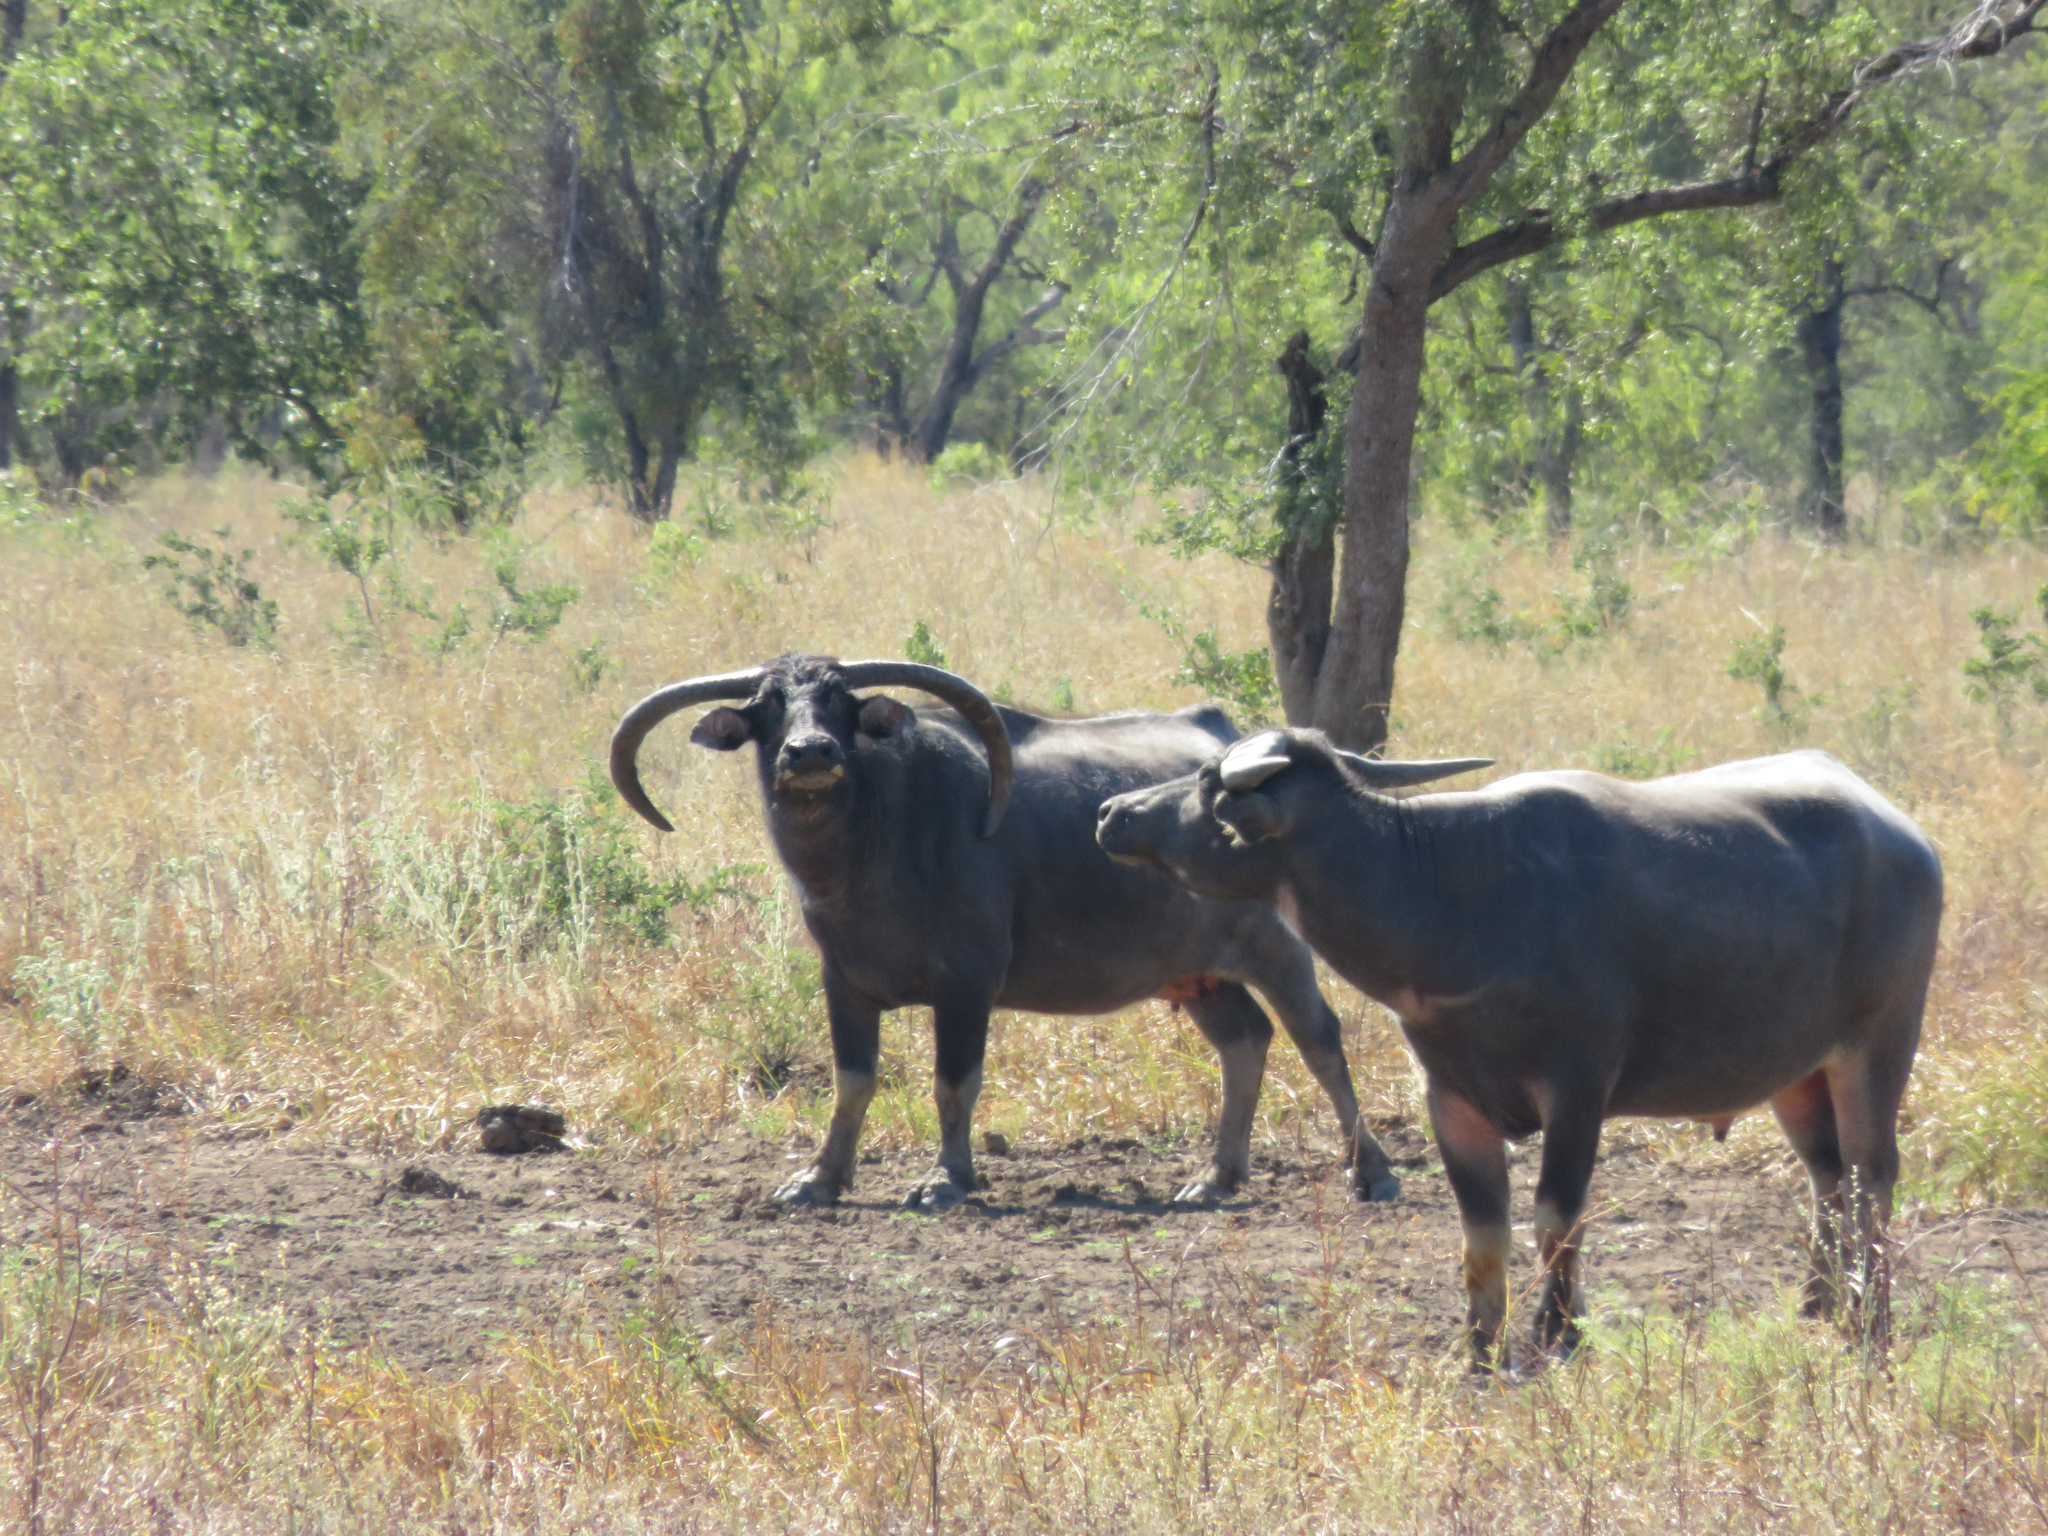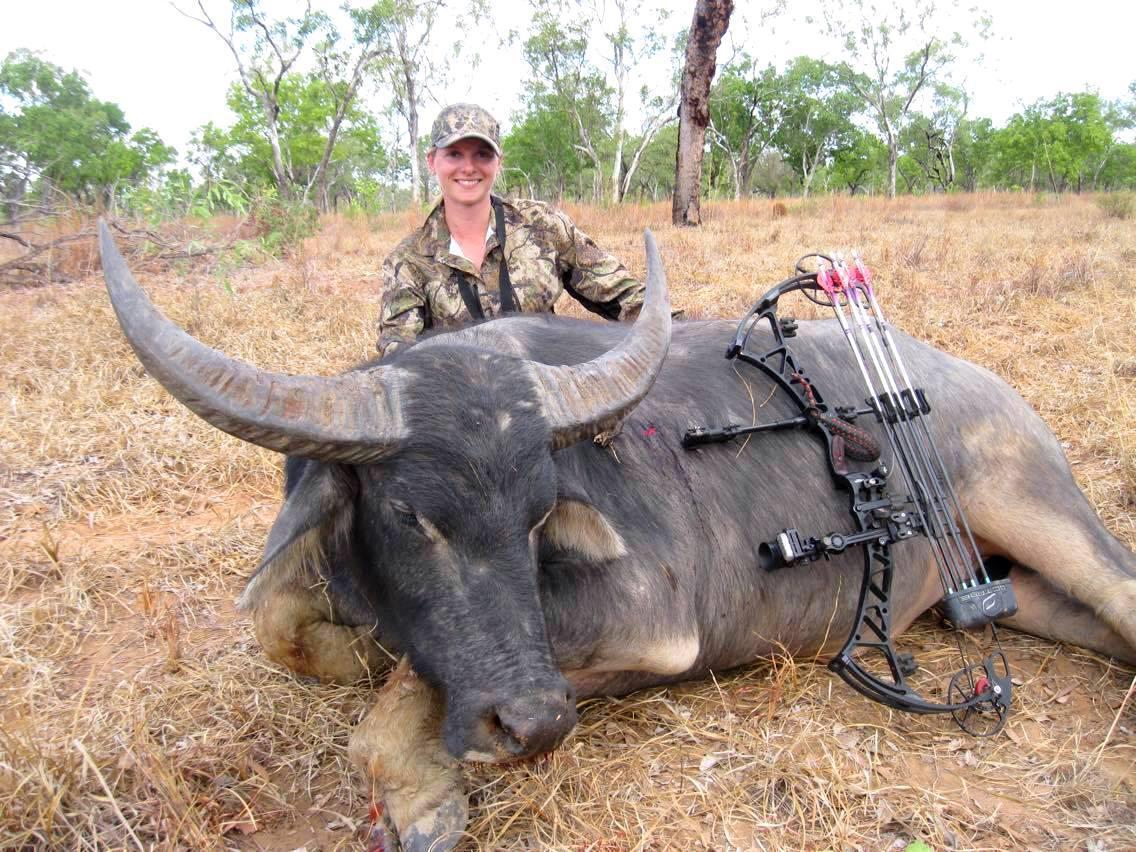The first image is the image on the left, the second image is the image on the right. Given the left and right images, does the statement "An image contains at least one person behind a dead water buffalo." hold true? Answer yes or no. Yes. The first image is the image on the left, the second image is the image on the right. Analyze the images presented: Is the assertion "There is at least one human in one of the images near a buffalo." valid? Answer yes or no. Yes. 